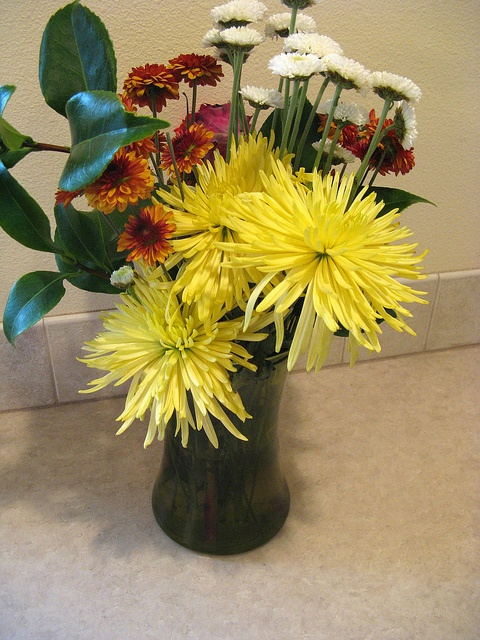Describe the objects in this image and their specific colors. I can see potted plant in darkgray, black, tan, olive, and khaki tones and vase in darkgray, black, darkgreen, and olive tones in this image. 